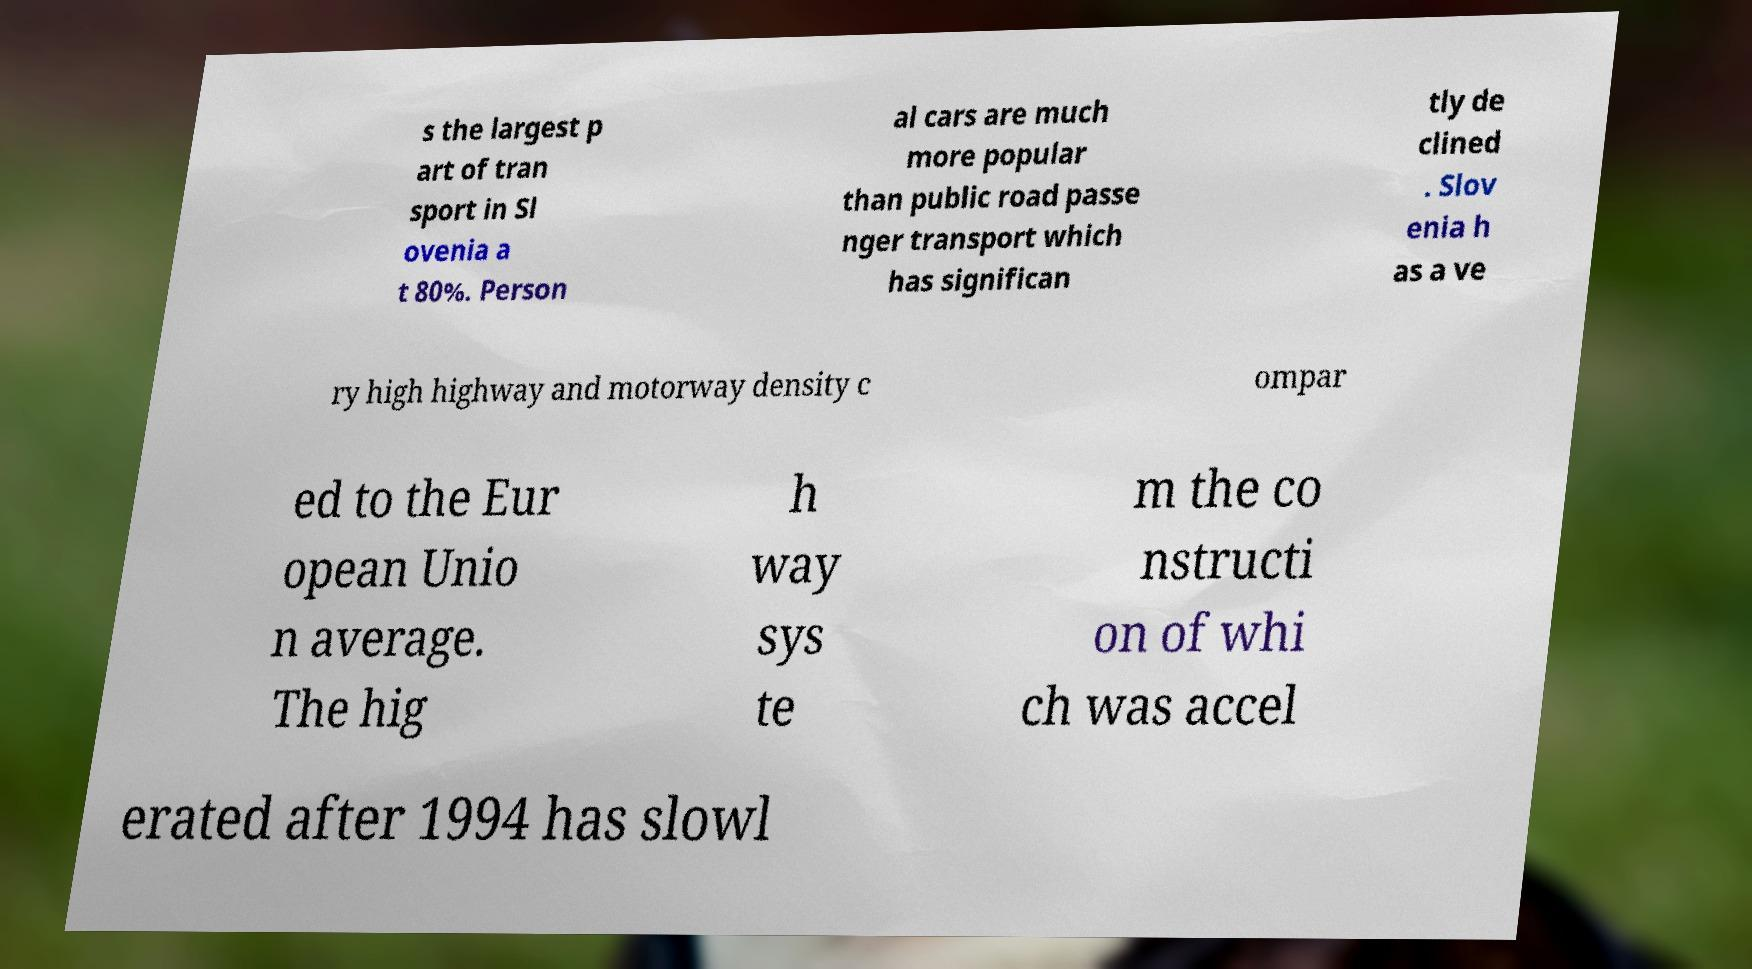Could you assist in decoding the text presented in this image and type it out clearly? s the largest p art of tran sport in Sl ovenia a t 80%. Person al cars are much more popular than public road passe nger transport which has significan tly de clined . Slov enia h as a ve ry high highway and motorway density c ompar ed to the Eur opean Unio n average. The hig h way sys te m the co nstructi on of whi ch was accel erated after 1994 has slowl 